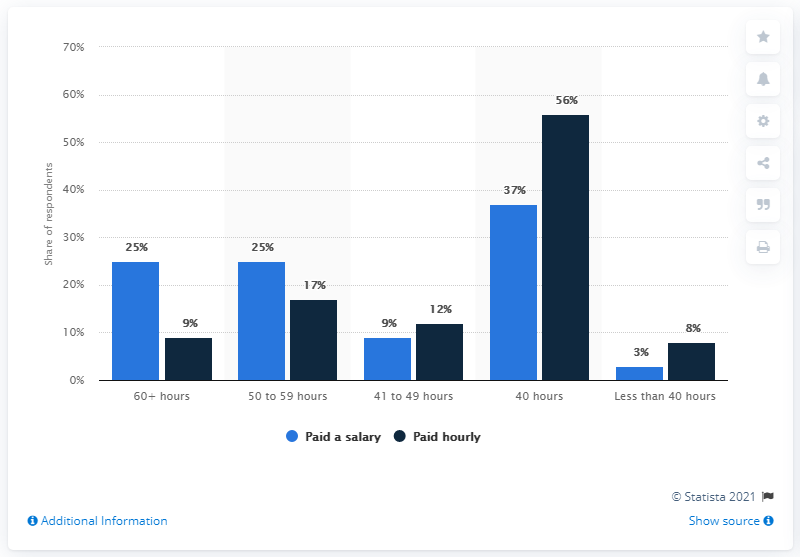Give some essential details in this illustration. The color bar that recorded the highest value in the chart is navy blue. The average of 40 hours is 46.5 hours. 